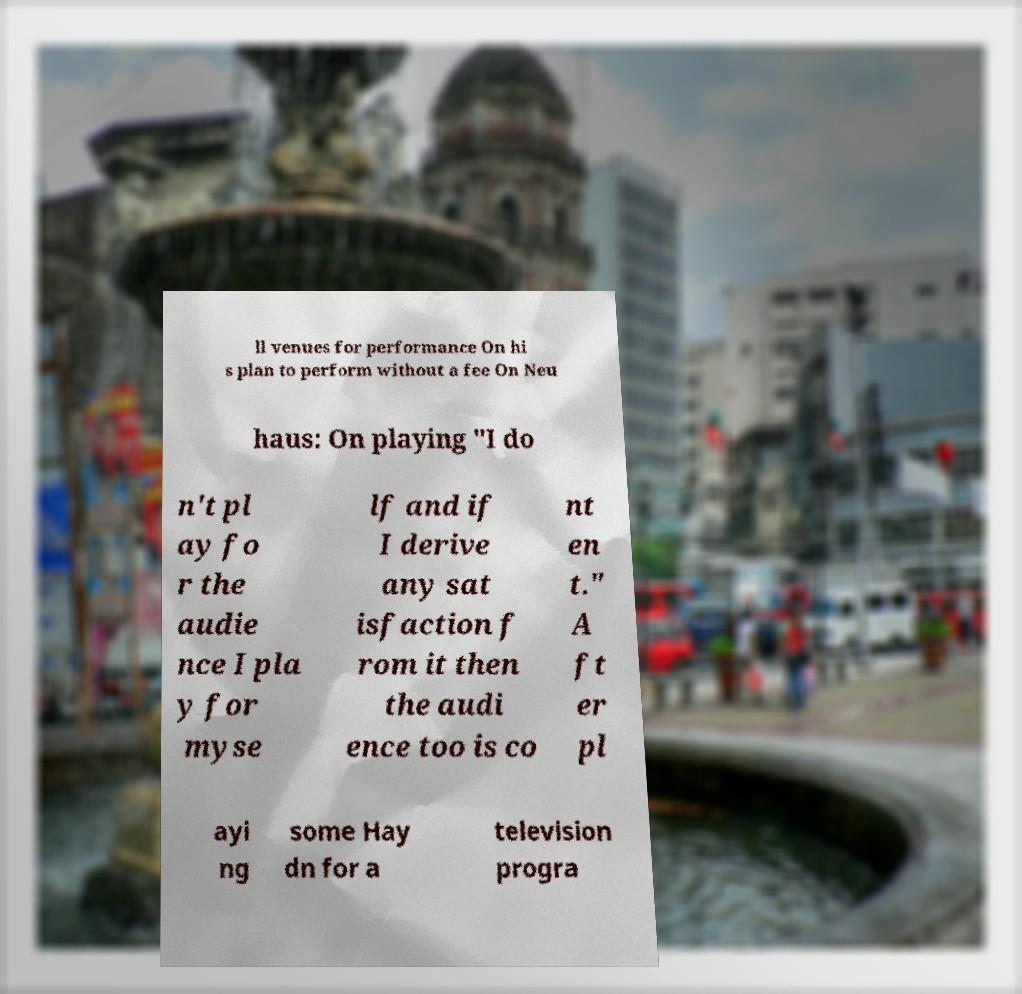For documentation purposes, I need the text within this image transcribed. Could you provide that? ll venues for performance On hi s plan to perform without a fee On Neu haus: On playing "I do n't pl ay fo r the audie nce I pla y for myse lf and if I derive any sat isfaction f rom it then the audi ence too is co nt en t." A ft er pl ayi ng some Hay dn for a television progra 